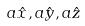Convert formula to latex. <formula><loc_0><loc_0><loc_500><loc_500>a \hat { x } , a \hat { y } , a \hat { z }</formula> 